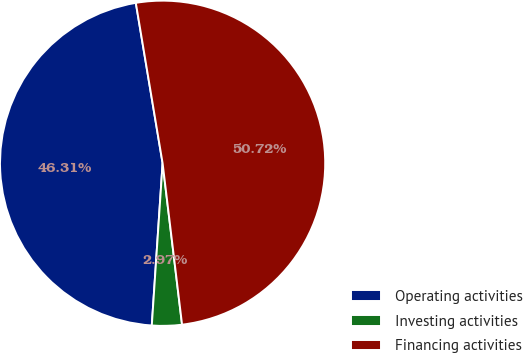Convert chart. <chart><loc_0><loc_0><loc_500><loc_500><pie_chart><fcel>Operating activities<fcel>Investing activities<fcel>Financing activities<nl><fcel>46.31%<fcel>2.97%<fcel>50.73%<nl></chart> 